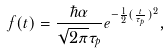<formula> <loc_0><loc_0><loc_500><loc_500>f ( t ) = \frac { \hbar { \alpha } } { \sqrt { 2 \pi } \tau _ { p } } e ^ { - \frac { 1 } { 2 } ( \frac { t } { \tau _ { p } } ) ^ { 2 } } ,</formula> 